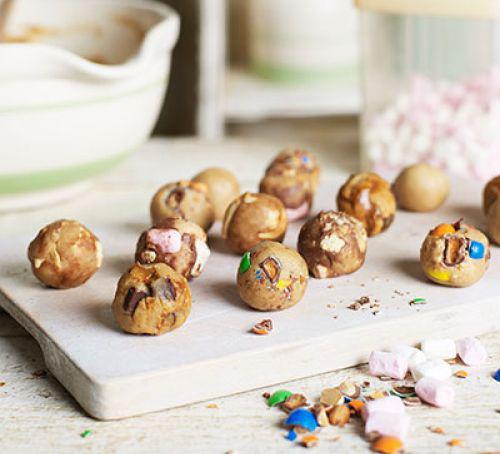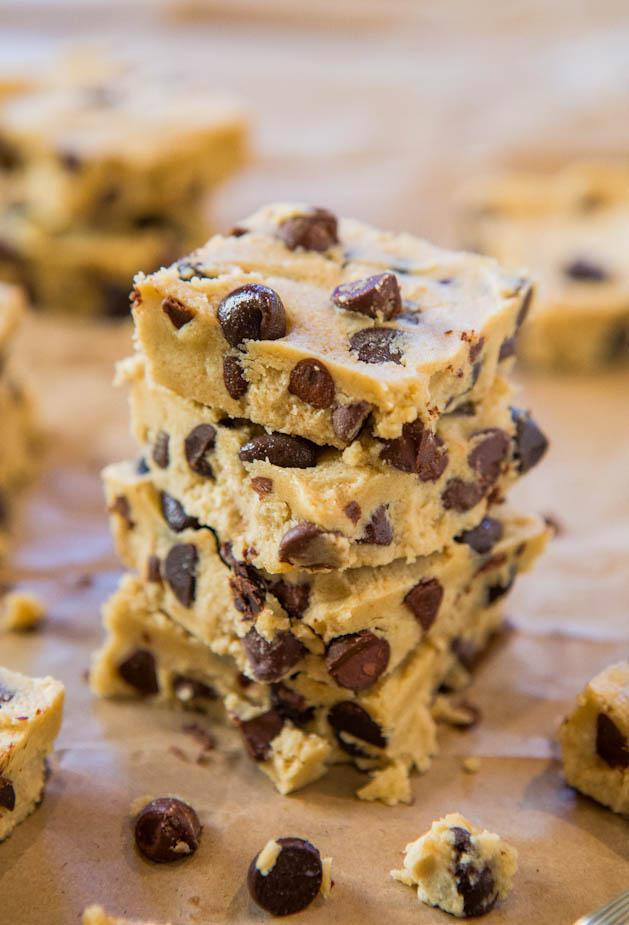The first image is the image on the left, the second image is the image on the right. Analyze the images presented: Is the assertion "A wooden spoon touching dough is visible." valid? Answer yes or no. No. The first image is the image on the left, the second image is the image on the right. Analyze the images presented: Is the assertion "Someone is using a wooden spoon to make chocolate chip cookies in one of the pictures." valid? Answer yes or no. No. 